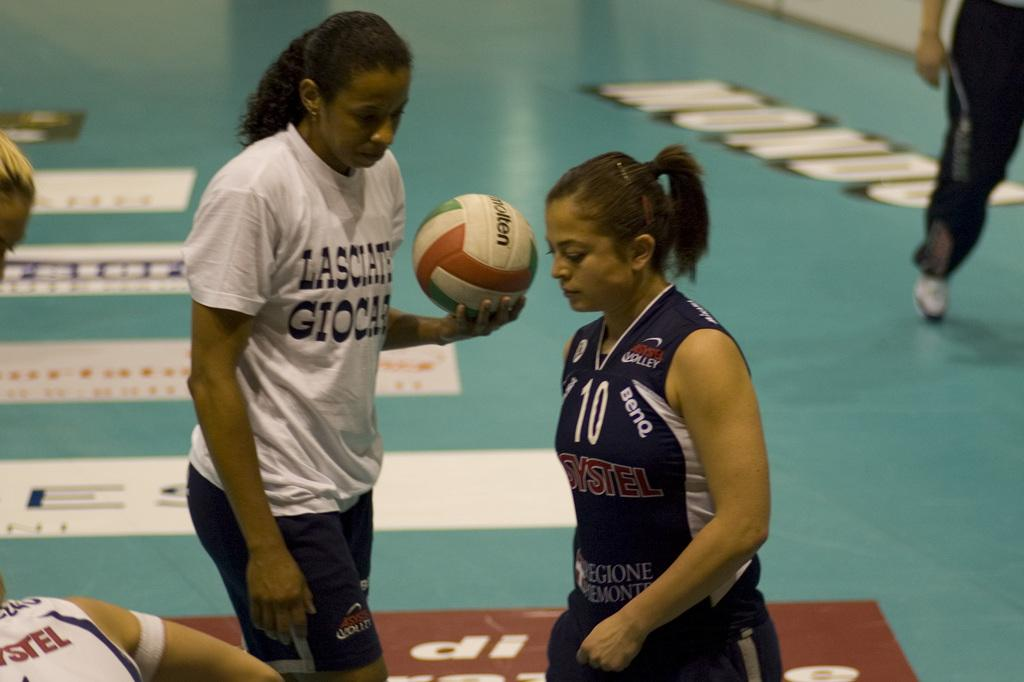How many girls are present in the image? There are two girls in the image. What is one of the girls holding in her hand? One of the girls is holding a ball in her hand. Can you describe the setting where the girls are located? The setting appears to be a play field. What type of yoke can be seen being used by the girls in the image? There is no yoke present in the image, and therefore no such activity can be observed. What company is sponsoring the girls in the image? There is no indication of any company sponsoring the girls in the image. 